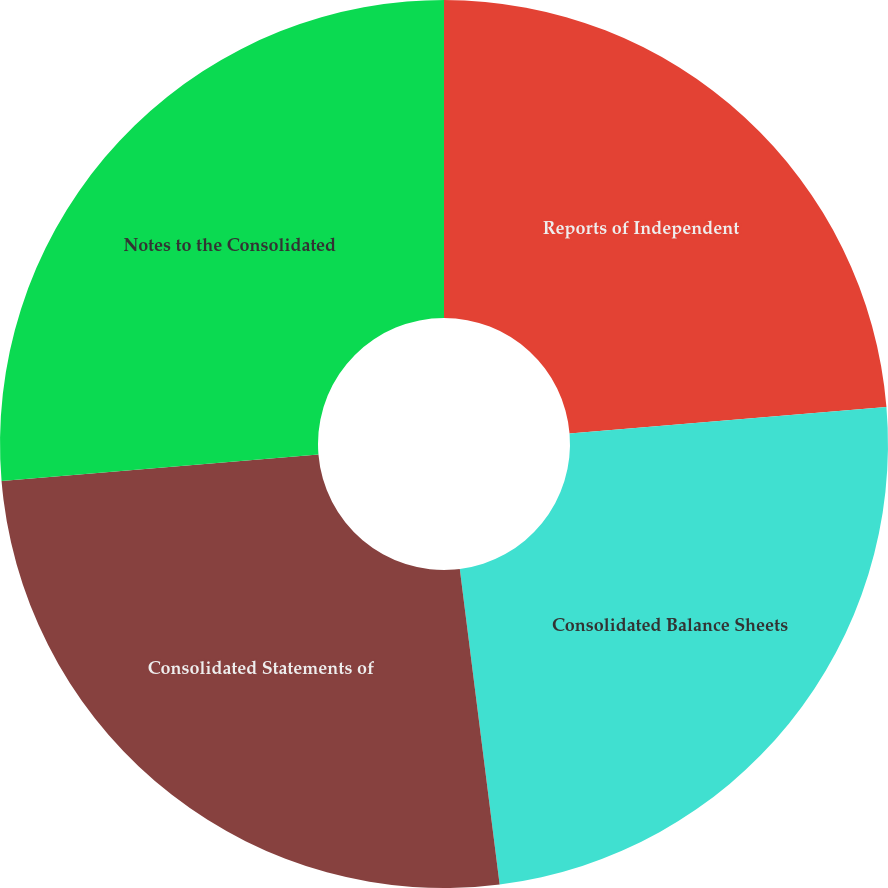Convert chart to OTSL. <chart><loc_0><loc_0><loc_500><loc_500><pie_chart><fcel>Reports of Independent<fcel>Consolidated Balance Sheets<fcel>Consolidated Statements of<fcel>Notes to the Consolidated<nl><fcel>23.67%<fcel>24.33%<fcel>25.67%<fcel>26.33%<nl></chart> 